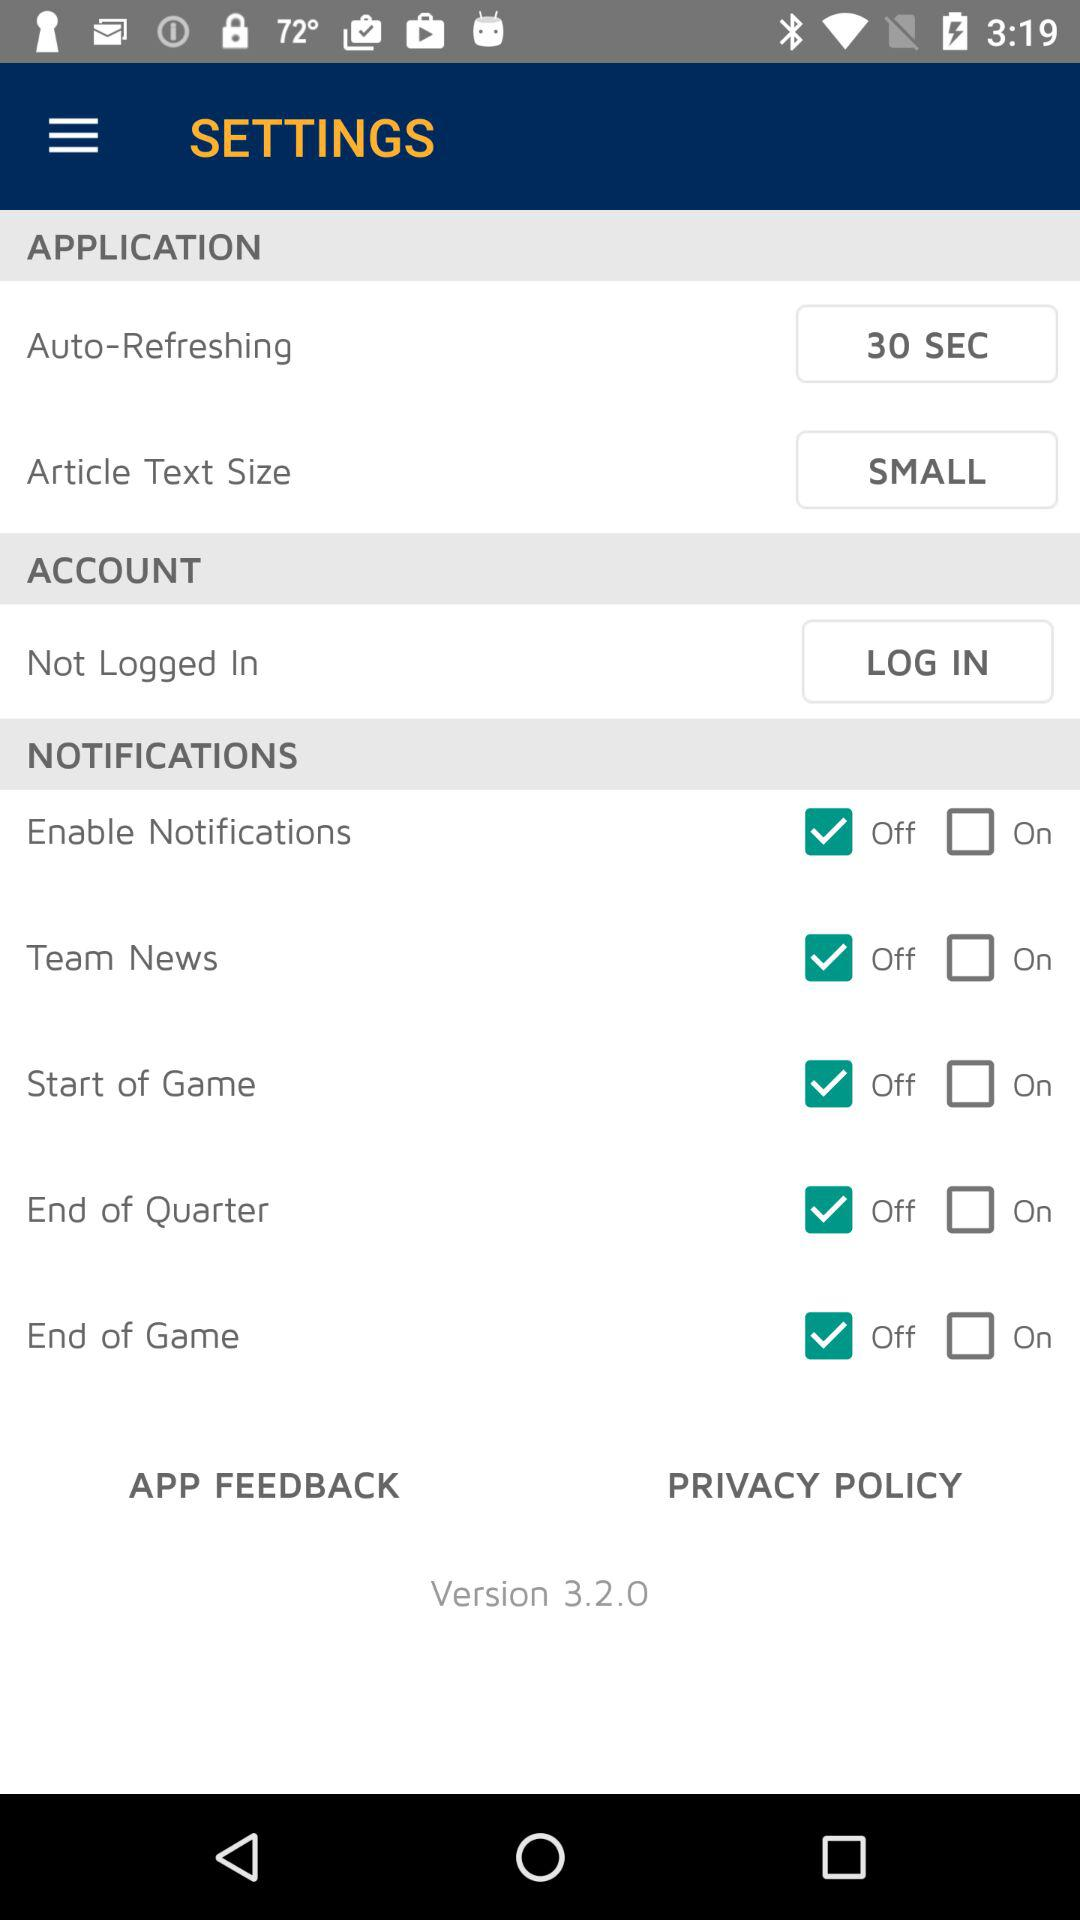What is the version of the application? The version is 3.2.0. 